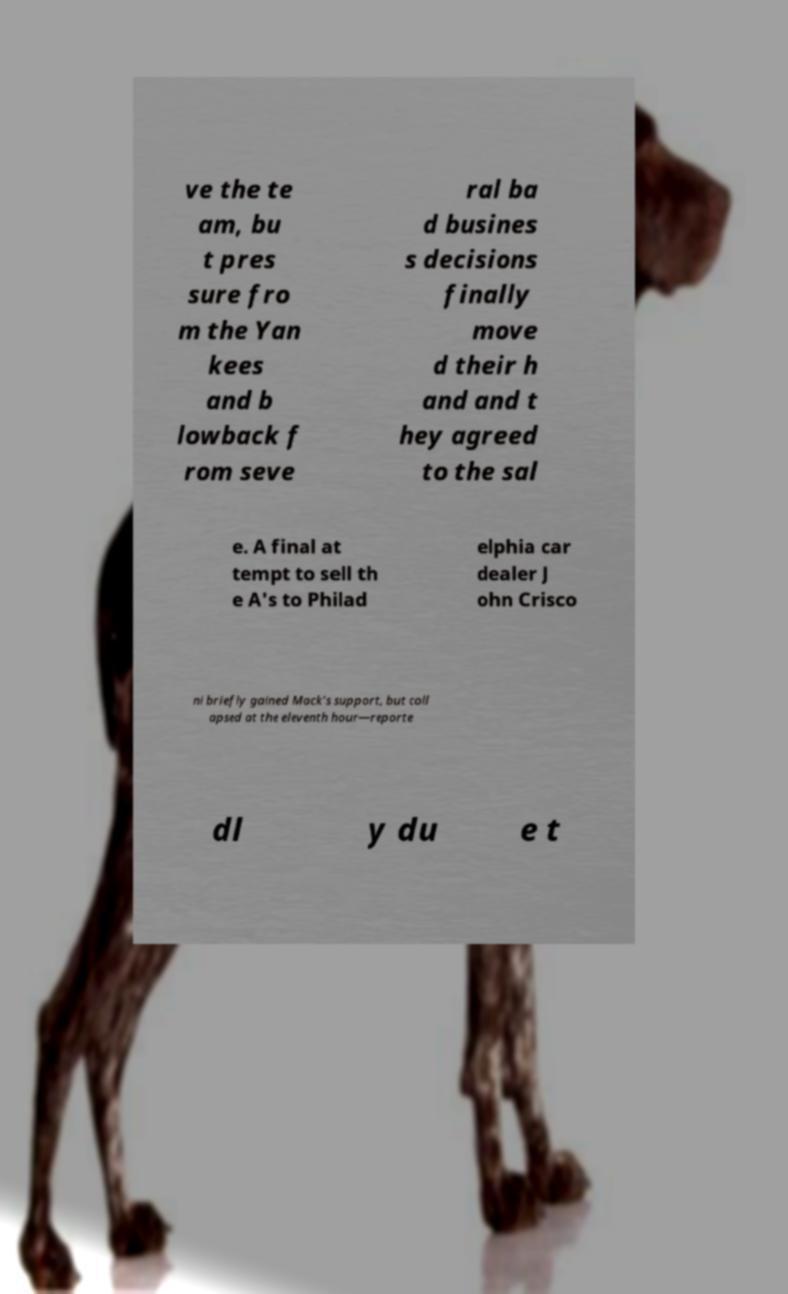I need the written content from this picture converted into text. Can you do that? ve the te am, bu t pres sure fro m the Yan kees and b lowback f rom seve ral ba d busines s decisions finally move d their h and and t hey agreed to the sal e. A final at tempt to sell th e A's to Philad elphia car dealer J ohn Crisco ni briefly gained Mack's support, but coll apsed at the eleventh hour—reporte dl y du e t 